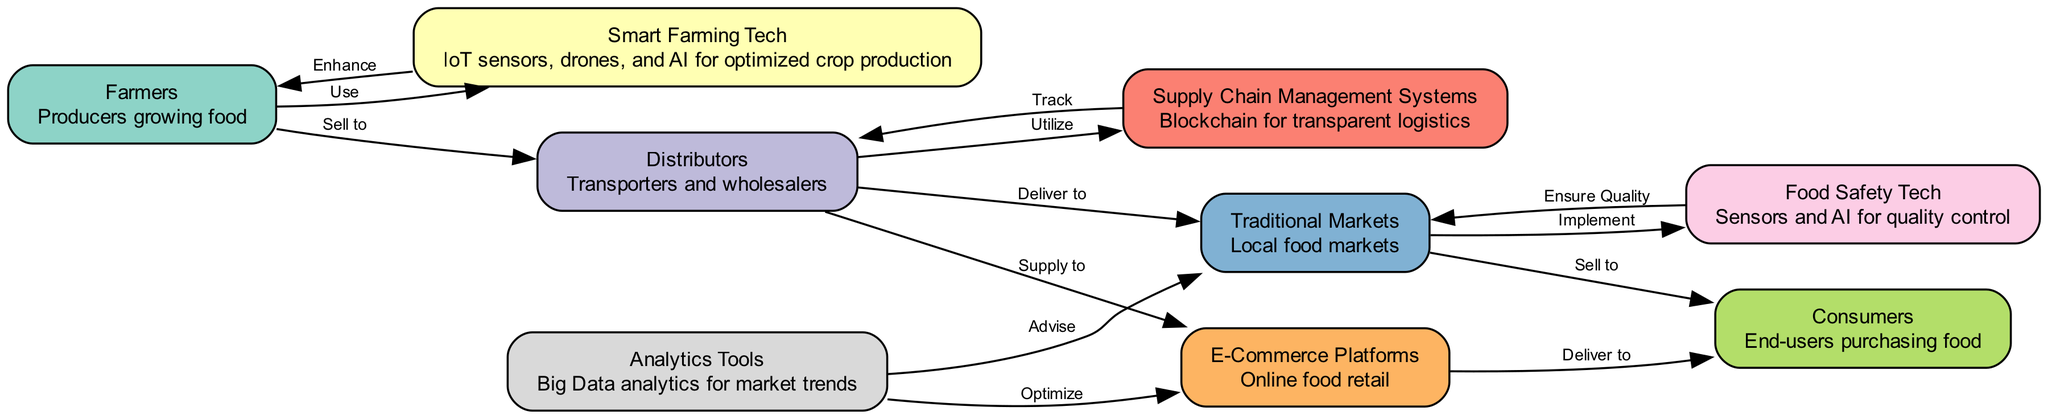What is the total number of nodes in the diagram? The diagram has 9 distinct nodes representing elements in the food chain, including farmers, smart farming tech, distributors, supply chain management, markets, e-commerce, consumers, food safety tech, and analytics tools. Counting these, we arrive at a total of 9 nodes.
Answer: 9 Which technology is used by farmers to optimize crop production? According to the diagram, smart farming tech is employed by farmers to enhance their crop production through IoT sensors, drones, and AI. The edge labeled "Use" connects farmers to smart farming tech, indicating utilization of this technology.
Answer: Smart Farming Tech How do distributors interact with e-commerce platforms? The diagram shows an edge labeled "Supply to" that connects distributors to e-commerce platforms, indicating that distributors supply food products to these online retail channels. This means distributors facilitate the availability of food products on e-commerce platforms.
Answer: Supply to What technology is implemented in traditional markets to ensure food quality? Food safety tech is shown to be implemented in traditional markets as indicated by the edge labeled "Implement" connecting was linked between markets and food safety tech. This technology employs sensors and AI to ensure the quality of food offered to consumers.
Answer: Food Safety Tech Who ultimately purchases the food products in this chain? Based on the diagram, consumers are positioned as the end-users who purchase food products supplied first by markets and also through e-commerce platforms. The edge labeled "Sell to" highlights this direct relationship.
Answer: Consumers How many edges are there in the diagram? The diagram consists of 12 edges representing the various relationships and interactions between the nodes in the food chain. By counting each of these connections, we confirm there are 12 edges.
Answer: 12 Which node advises traditional markets on market trends? The diagram indicates that analytics tools provide advice to traditional markets, as shown by the edge labeled "Advise" connecting analytics to markets. This suggests analytics tools analyze large datasets to inform market strategies.
Answer: Analytics Tools What do distributors use to manage supply chain logistics? Distributors utilize supply chain management systems, as indicated by the edge labeled "Utilize" connecting distributors to supply chain management. This system often involves technologies like blockchain for transparent logistics in food distribution.
Answer: Supply Chain Management Systems How is food delivered to consumers using e-commerce? The diagram states that food products are delivered to consumers via e-commerce platforms, which is illustrated by the edge labeled "Deliver to" between e-commerce and consumers. This highlights the process of purchasing food online and its subsequent delivery.
Answer: Deliver to 